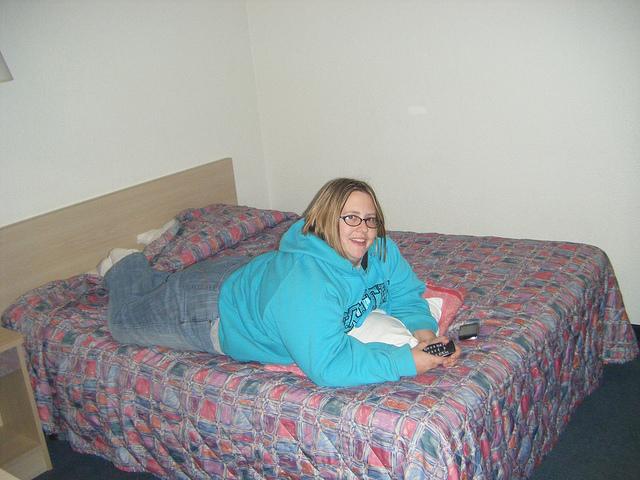Does the headboard of the bed appear to be wooden?
Short answer required. Yes. Is this a male or female?
Keep it brief. Female. Is this person wearing glasses?
Be succinct. Yes. 